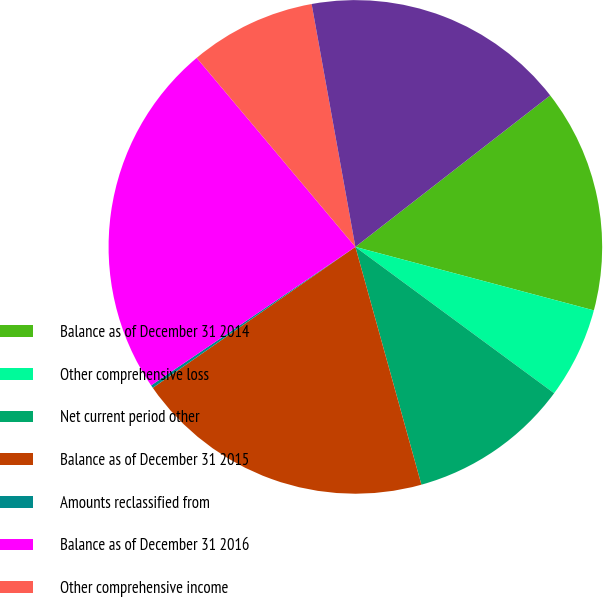Convert chart to OTSL. <chart><loc_0><loc_0><loc_500><loc_500><pie_chart><fcel>Balance as of December 31 2014<fcel>Other comprehensive loss<fcel>Net current period other<fcel>Balance as of December 31 2015<fcel>Amounts reclassified from<fcel>Balance as of December 31 2016<fcel>Other comprehensive income<fcel>Balance as of December 31 2017<nl><fcel>14.66%<fcel>5.96%<fcel>10.59%<fcel>19.64%<fcel>0.19%<fcel>23.37%<fcel>8.28%<fcel>17.32%<nl></chart> 